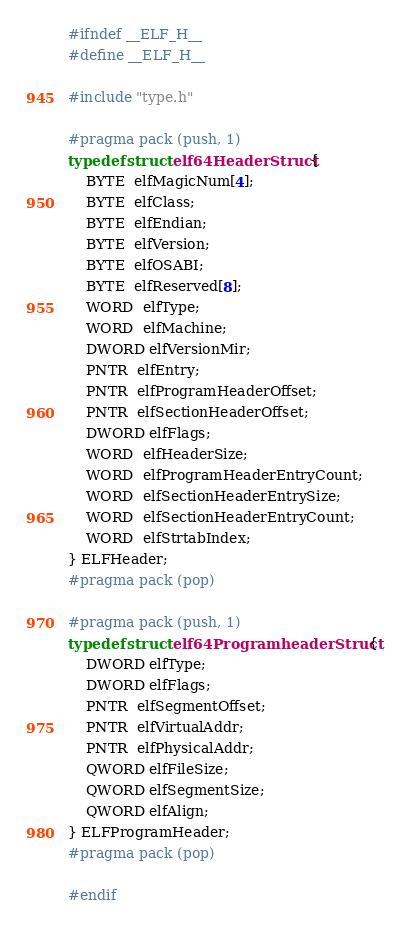Convert code to text. <code><loc_0><loc_0><loc_500><loc_500><_C_>#ifndef __ELF_H__
#define __ELF_H__

#include "type.h"

#pragma pack (push, 1)
typedef struct elf64HeaderStruct {
	BYTE  elfMagicNum[4];
	BYTE  elfClass;
	BYTE  elfEndian;
	BYTE  elfVersion;
	BYTE  elfOSABI;
	BYTE  elfReserved[8];
	WORD  elfType;
	WORD  elfMachine;
	DWORD elfVersionMir;
	PNTR  elfEntry;
	PNTR  elfProgramHeaderOffset;
	PNTR  elfSectionHeaderOffset;
	DWORD elfFlags;
	WORD  elfHeaderSize;
	WORD  elfProgramHeaderEntryCount;
	WORD  elfSectionHeaderEntrySize;
	WORD  elfSectionHeaderEntryCount;
	WORD  elfStrtabIndex;
} ELFHeader;
#pragma pack (pop)

#pragma pack (push, 1)
typedef struct elf64ProgramheaderStruct {
	DWORD elfType;
	DWORD elfFlags;
	PNTR  elfSegmentOffset;
	PNTR  elfVirtualAddr;
	PNTR  elfPhysicalAddr;
	QWORD elfFileSize;
	QWORD elfSegmentSize;
	QWORD elfAlign;
} ELFProgramHeader;
#pragma pack (pop)

#endif
</code> 